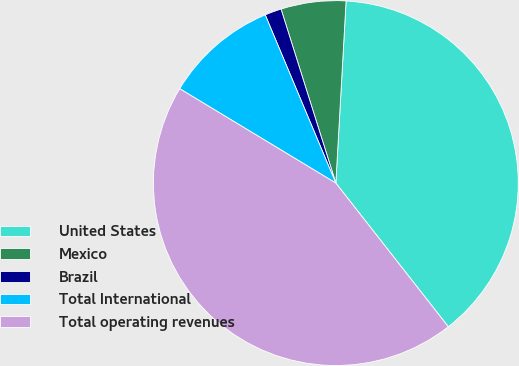Convert chart to OTSL. <chart><loc_0><loc_0><loc_500><loc_500><pie_chart><fcel>United States<fcel>Mexico<fcel>Brazil<fcel>Total International<fcel>Total operating revenues<nl><fcel>38.53%<fcel>5.75%<fcel>1.47%<fcel>10.02%<fcel>44.22%<nl></chart> 